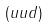<formula> <loc_0><loc_0><loc_500><loc_500>( u u d )</formula> 